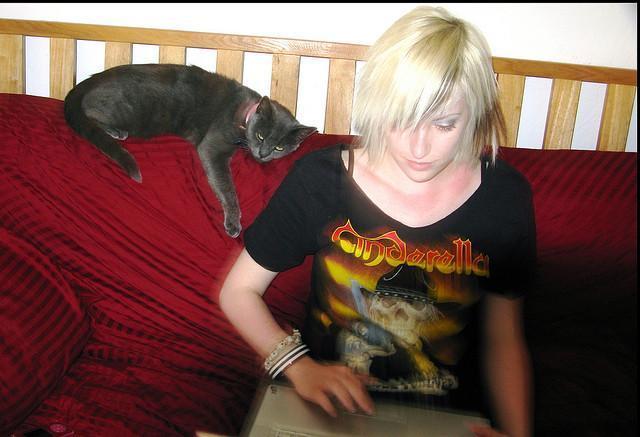Is this affirmation: "The person is in the middle of the couch." correct?
Answer yes or no. Yes. 